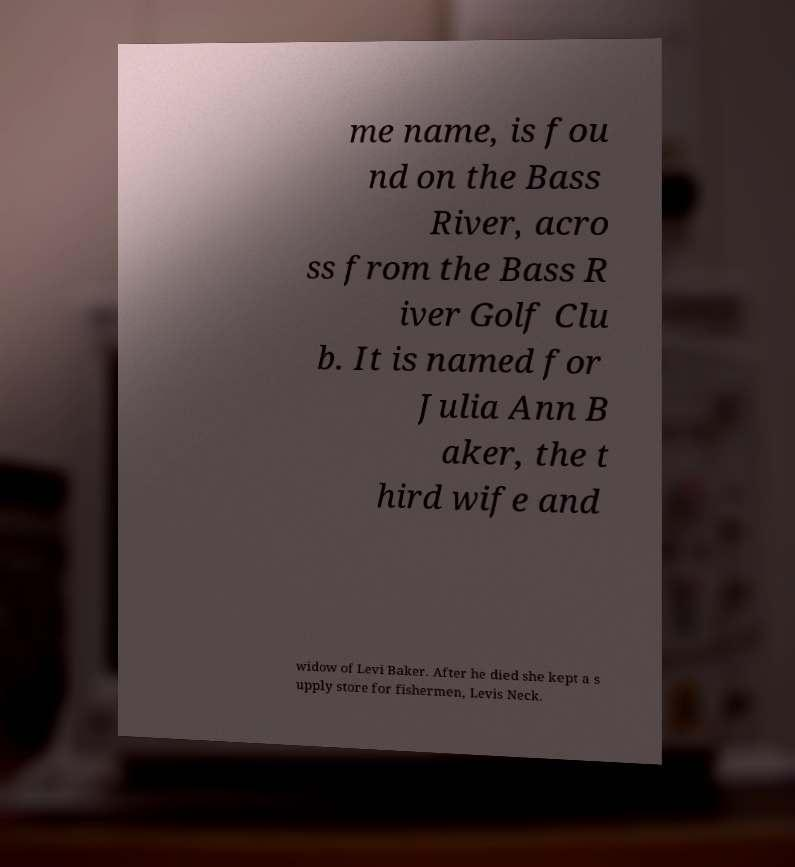Please read and relay the text visible in this image. What does it say? me name, is fou nd on the Bass River, acro ss from the Bass R iver Golf Clu b. It is named for Julia Ann B aker, the t hird wife and widow of Levi Baker. After he died she kept a s upply store for fishermen, Levis Neck. 